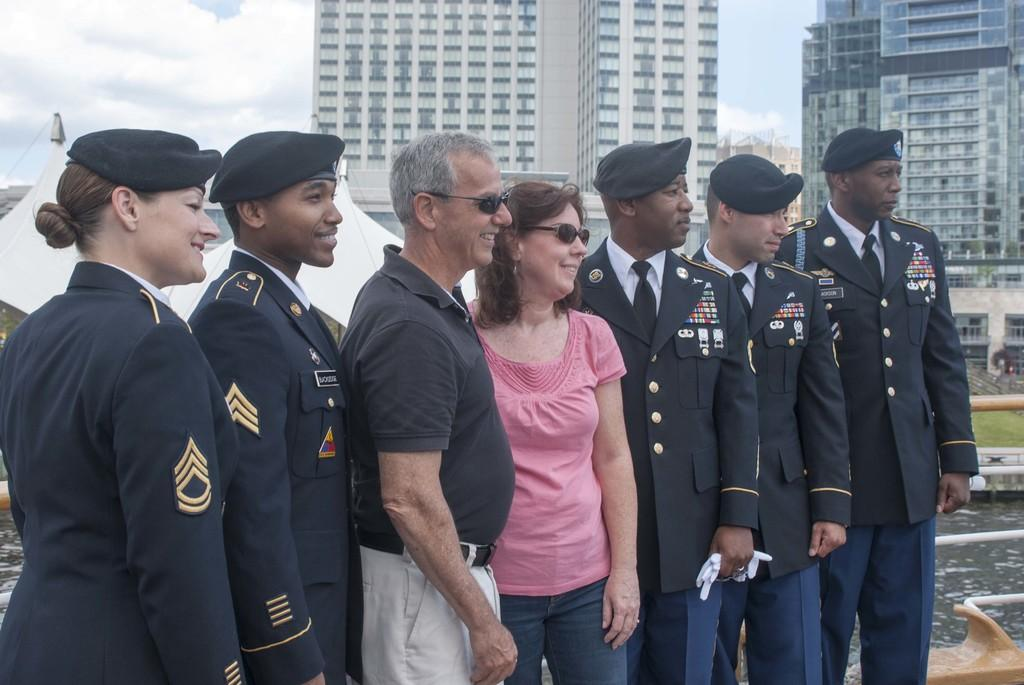What is happening in the image? There are people standing in the image. What can be seen in the distance behind the people? There are buildings and tents in the background of the image. What is on the right side of the image? There is water visible on the right side of the image. What objects are near the water? There are rods visible near the water. What is visible in the sky in the image? The sky is visible in the background of the image. What song is being sung by the people in the image? There is no indication in the image that the people are singing a song, so it cannot be determined from the picture. 